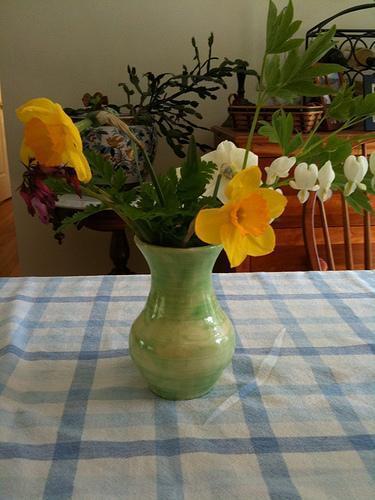How many yellow flowers?
Give a very brief answer. 2. 